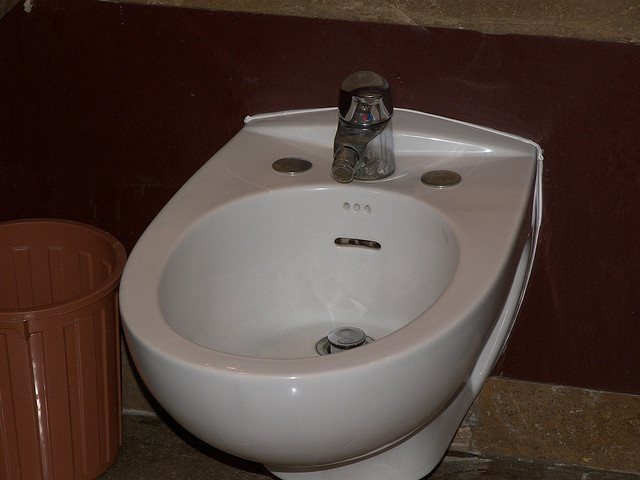Describe the objects in this image and their specific colors. I can see a sink in black, darkgray, and gray tones in this image. 